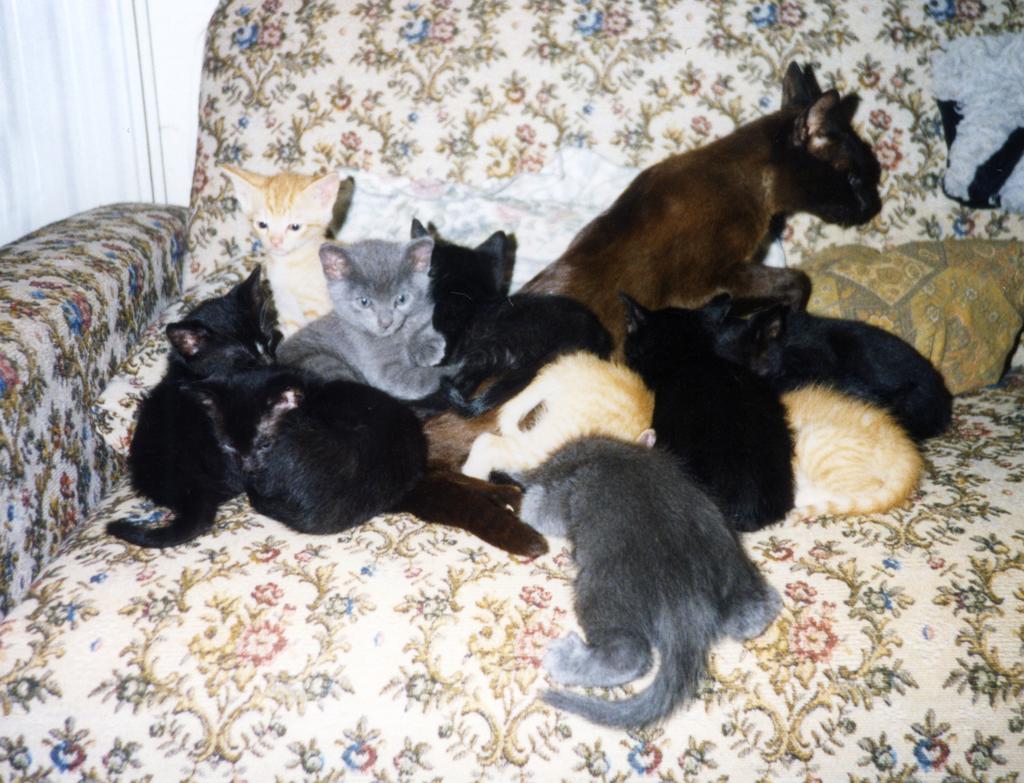How would you summarize this image in a sentence or two? In this image there are group of cats sitting on the couch, there is a pillow on the couch, there is an object truncated towards the right of the image, the background of the image is white in color. 